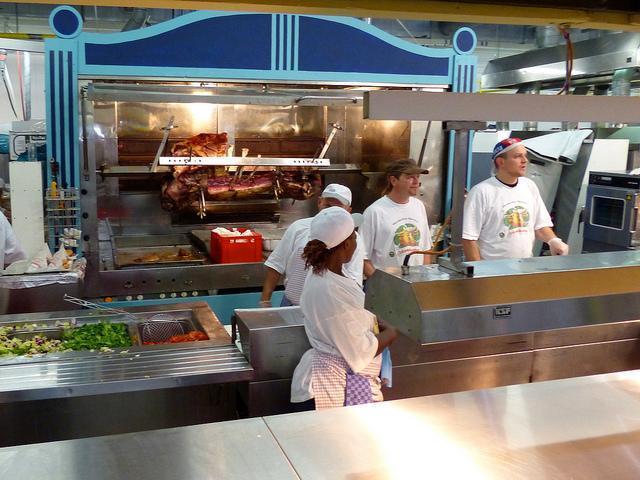How many people are in the picture?
Give a very brief answer. 4. How many ovens are in the picture?
Give a very brief answer. 3. How many vases are blue?
Give a very brief answer. 0. 